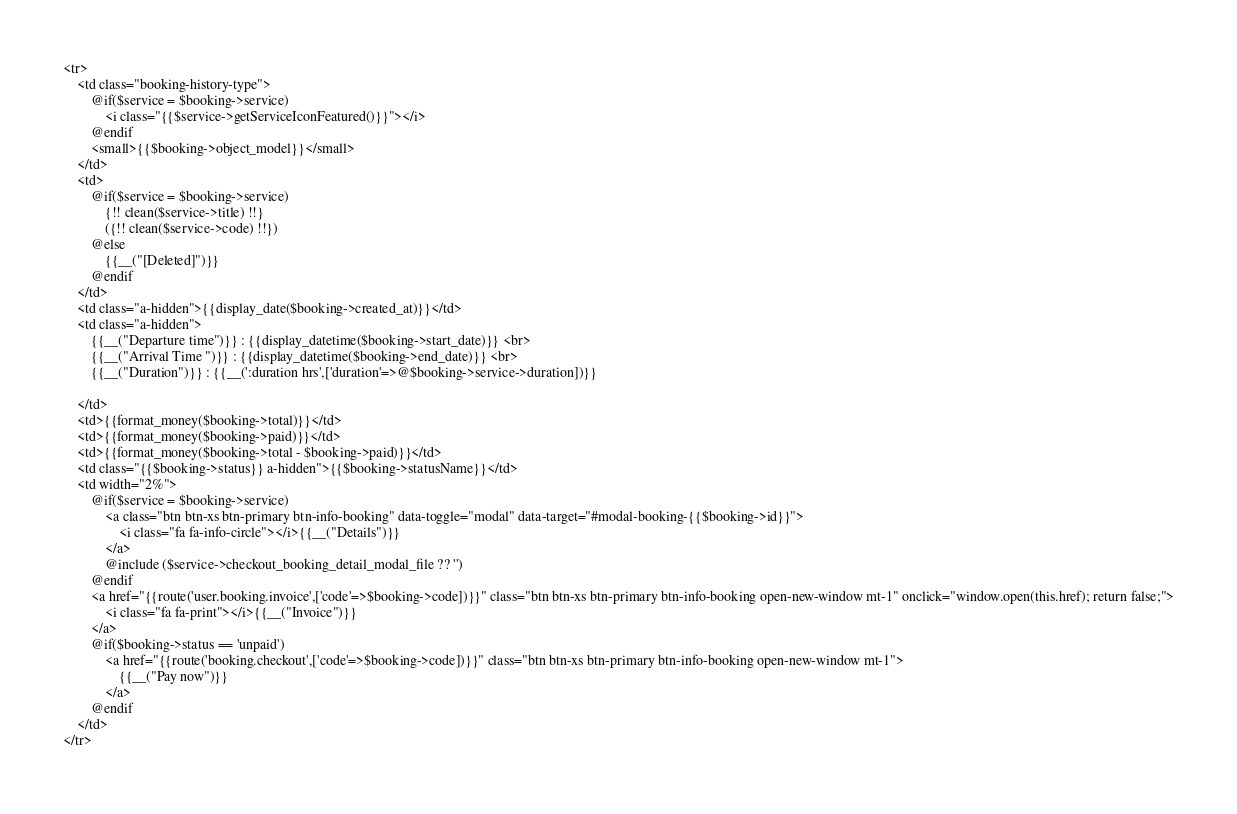<code> <loc_0><loc_0><loc_500><loc_500><_PHP_><tr>
    <td class="booking-history-type">
        @if($service = $booking->service)
            <i class="{{$service->getServiceIconFeatured()}}"></i>
        @endif
        <small>{{$booking->object_model}}</small>
    </td>
    <td>
        @if($service = $booking->service)
            {!! clean($service->title) !!}
            ({!! clean($service->code) !!})
        @else
            {{__("[Deleted]")}}
        @endif
    </td>
    <td class="a-hidden">{{display_date($booking->created_at)}}</td>
    <td class="a-hidden">
        {{__("Departure time")}} : {{display_datetime($booking->start_date)}} <br>
        {{__("Arrival Time ")}} : {{display_datetime($booking->end_date)}} <br>
        {{__("Duration")}} : {{__(':duration hrs',['duration'=>@$booking->service->duration])}}
       
    </td>
    <td>{{format_money($booking->total)}}</td>
    <td>{{format_money($booking->paid)}}</td>
    <td>{{format_money($booking->total - $booking->paid)}}</td>
    <td class="{{$booking->status}} a-hidden">{{$booking->statusName}}</td>
    <td width="2%">
        @if($service = $booking->service)
            <a class="btn btn-xs btn-primary btn-info-booking" data-toggle="modal" data-target="#modal-booking-{{$booking->id}}">
                <i class="fa fa-info-circle"></i>{{__("Details")}}
            </a>
            @include ($service->checkout_booking_detail_modal_file ?? '')
        @endif
        <a href="{{route('user.booking.invoice',['code'=>$booking->code])}}" class="btn btn-xs btn-primary btn-info-booking open-new-window mt-1" onclick="window.open(this.href); return false;">
            <i class="fa fa-print"></i>{{__("Invoice")}}
        </a>
        @if($booking->status == 'unpaid')
            <a href="{{route('booking.checkout',['code'=>$booking->code])}}" class="btn btn-xs btn-primary btn-info-booking open-new-window mt-1">
                {{__("Pay now")}}
            </a>
        @endif
    </td>
</tr>
</code> 